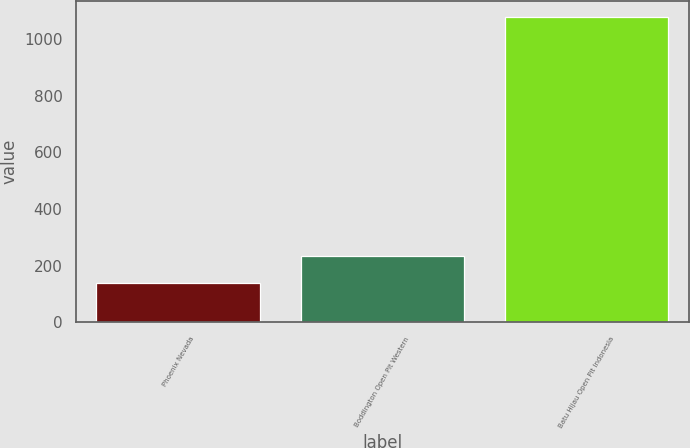Convert chart. <chart><loc_0><loc_0><loc_500><loc_500><bar_chart><fcel>Phoenix Nevada<fcel>Boddington Open Pit Western<fcel>Batu Hijau Open Pit Indonesia<nl><fcel>140<fcel>234<fcel>1080<nl></chart> 